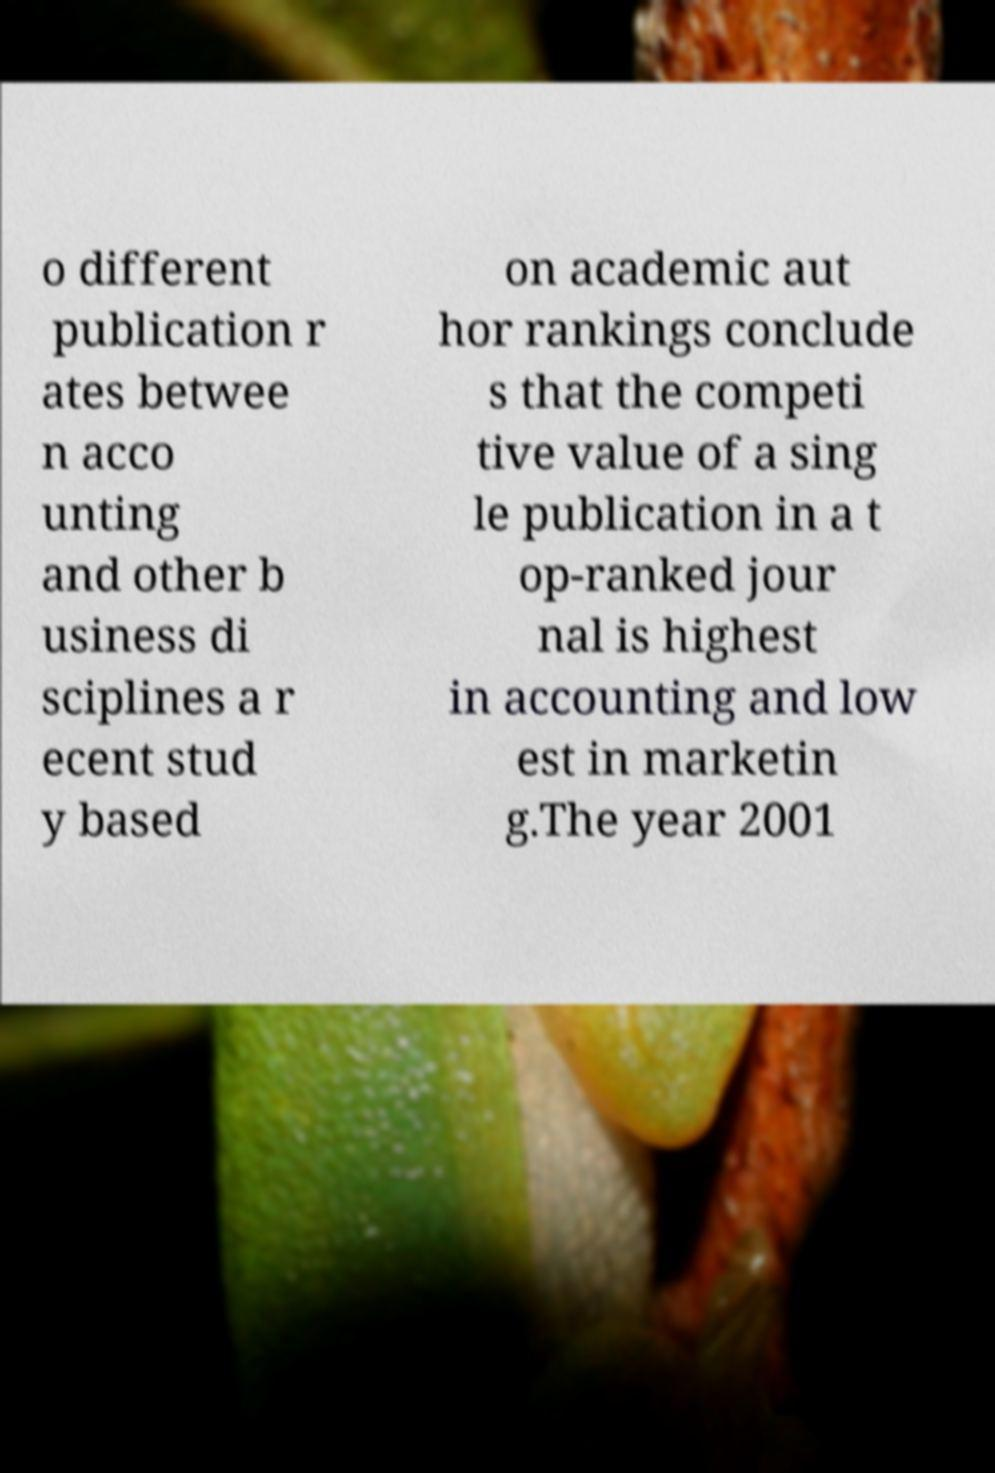Can you read and provide the text displayed in the image?This photo seems to have some interesting text. Can you extract and type it out for me? o different publication r ates betwee n acco unting and other b usiness di sciplines a r ecent stud y based on academic aut hor rankings conclude s that the competi tive value of a sing le publication in a t op-ranked jour nal is highest in accounting and low est in marketin g.The year 2001 